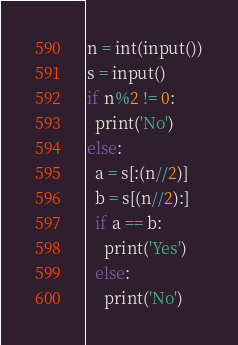Convert code to text. <code><loc_0><loc_0><loc_500><loc_500><_Python_>n = int(input())
s = input()
if n%2 != 0:
  print('No')
else:
  a = s[:(n//2)]
  b = s[(n//2):]
  if a == b:
    print('Yes')
  else:
    print('No')</code> 